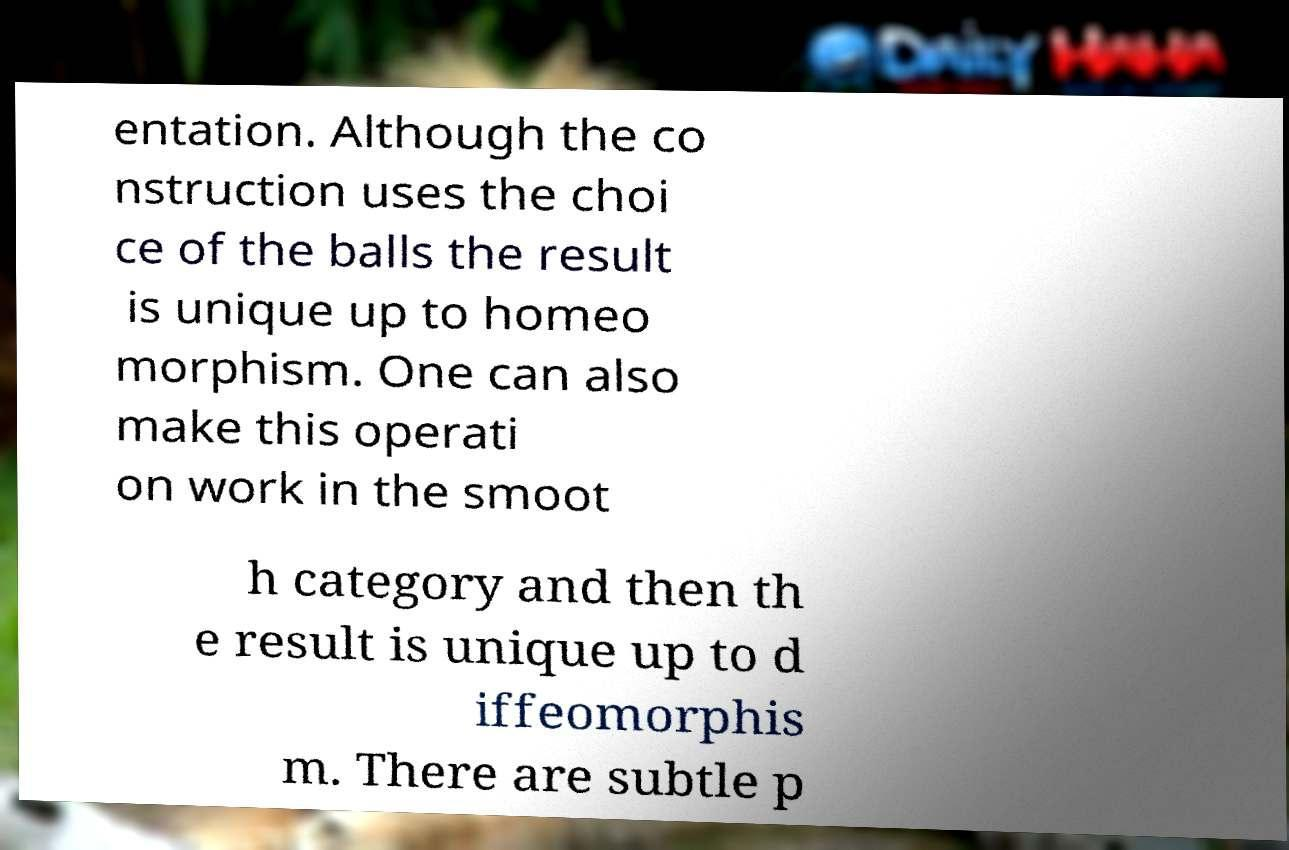Can you read and provide the text displayed in the image?This photo seems to have some interesting text. Can you extract and type it out for me? entation. Although the co nstruction uses the choi ce of the balls the result is unique up to homeo morphism. One can also make this operati on work in the smoot h category and then th e result is unique up to d iffeomorphis m. There are subtle p 